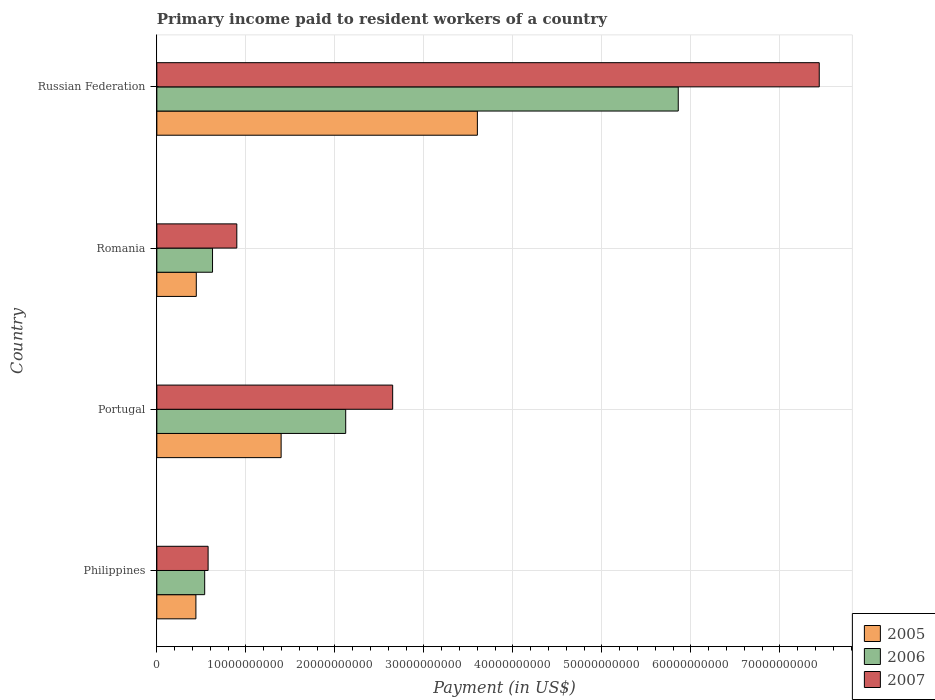Are the number of bars per tick equal to the number of legend labels?
Ensure brevity in your answer.  Yes. Are the number of bars on each tick of the Y-axis equal?
Offer a terse response. Yes. How many bars are there on the 1st tick from the top?
Your answer should be compact. 3. How many bars are there on the 2nd tick from the bottom?
Give a very brief answer. 3. What is the label of the 1st group of bars from the top?
Keep it short and to the point. Russian Federation. What is the amount paid to workers in 2007 in Russian Federation?
Offer a very short reply. 7.44e+1. Across all countries, what is the maximum amount paid to workers in 2006?
Ensure brevity in your answer.  5.86e+1. Across all countries, what is the minimum amount paid to workers in 2005?
Your answer should be very brief. 4.39e+09. In which country was the amount paid to workers in 2007 maximum?
Give a very brief answer. Russian Federation. What is the total amount paid to workers in 2005 in the graph?
Keep it short and to the point. 5.88e+1. What is the difference between the amount paid to workers in 2006 in Portugal and that in Romania?
Provide a succinct answer. 1.50e+1. What is the difference between the amount paid to workers in 2005 in Philippines and the amount paid to workers in 2006 in Portugal?
Your answer should be compact. -1.68e+1. What is the average amount paid to workers in 2006 per country?
Offer a very short reply. 2.29e+1. What is the difference between the amount paid to workers in 2007 and amount paid to workers in 2005 in Philippines?
Your answer should be compact. 1.37e+09. What is the ratio of the amount paid to workers in 2005 in Romania to that in Russian Federation?
Your response must be concise. 0.12. Is the amount paid to workers in 2006 in Philippines less than that in Romania?
Your response must be concise. Yes. Is the difference between the amount paid to workers in 2007 in Portugal and Romania greater than the difference between the amount paid to workers in 2005 in Portugal and Romania?
Provide a short and direct response. Yes. What is the difference between the highest and the second highest amount paid to workers in 2006?
Your answer should be compact. 3.74e+1. What is the difference between the highest and the lowest amount paid to workers in 2005?
Ensure brevity in your answer.  3.16e+1. In how many countries, is the amount paid to workers in 2005 greater than the average amount paid to workers in 2005 taken over all countries?
Keep it short and to the point. 1. Is the sum of the amount paid to workers in 2007 in Portugal and Russian Federation greater than the maximum amount paid to workers in 2006 across all countries?
Offer a terse response. Yes. What does the 3rd bar from the bottom in Philippines represents?
Provide a short and direct response. 2007. How many bars are there?
Your response must be concise. 12. How many countries are there in the graph?
Keep it short and to the point. 4. What is the difference between two consecutive major ticks on the X-axis?
Your response must be concise. 1.00e+1. Does the graph contain any zero values?
Provide a succinct answer. No. Where does the legend appear in the graph?
Provide a short and direct response. Bottom right. How many legend labels are there?
Give a very brief answer. 3. How are the legend labels stacked?
Your answer should be very brief. Vertical. What is the title of the graph?
Your response must be concise. Primary income paid to resident workers of a country. Does "1985" appear as one of the legend labels in the graph?
Keep it short and to the point. No. What is the label or title of the X-axis?
Your response must be concise. Payment (in US$). What is the label or title of the Y-axis?
Your answer should be very brief. Country. What is the Payment (in US$) of 2005 in Philippines?
Offer a terse response. 4.39e+09. What is the Payment (in US$) in 2006 in Philippines?
Make the answer very short. 5.37e+09. What is the Payment (in US$) of 2007 in Philippines?
Offer a very short reply. 5.76e+09. What is the Payment (in US$) of 2005 in Portugal?
Offer a very short reply. 1.40e+1. What is the Payment (in US$) of 2006 in Portugal?
Ensure brevity in your answer.  2.12e+1. What is the Payment (in US$) of 2007 in Portugal?
Give a very brief answer. 2.65e+1. What is the Payment (in US$) in 2005 in Romania?
Your answer should be very brief. 4.43e+09. What is the Payment (in US$) of 2006 in Romania?
Offer a terse response. 6.26e+09. What is the Payment (in US$) in 2007 in Romania?
Offer a very short reply. 8.98e+09. What is the Payment (in US$) of 2005 in Russian Federation?
Give a very brief answer. 3.60e+1. What is the Payment (in US$) in 2006 in Russian Federation?
Give a very brief answer. 5.86e+1. What is the Payment (in US$) of 2007 in Russian Federation?
Ensure brevity in your answer.  7.44e+1. Across all countries, what is the maximum Payment (in US$) in 2005?
Make the answer very short. 3.60e+1. Across all countries, what is the maximum Payment (in US$) in 2006?
Provide a short and direct response. 5.86e+1. Across all countries, what is the maximum Payment (in US$) of 2007?
Keep it short and to the point. 7.44e+1. Across all countries, what is the minimum Payment (in US$) of 2005?
Keep it short and to the point. 4.39e+09. Across all countries, what is the minimum Payment (in US$) of 2006?
Give a very brief answer. 5.37e+09. Across all countries, what is the minimum Payment (in US$) of 2007?
Offer a very short reply. 5.76e+09. What is the total Payment (in US$) of 2005 in the graph?
Provide a succinct answer. 5.88e+1. What is the total Payment (in US$) of 2006 in the graph?
Ensure brevity in your answer.  9.14e+1. What is the total Payment (in US$) in 2007 in the graph?
Offer a very short reply. 1.16e+11. What is the difference between the Payment (in US$) in 2005 in Philippines and that in Portugal?
Your answer should be compact. -9.57e+09. What is the difference between the Payment (in US$) in 2006 in Philippines and that in Portugal?
Make the answer very short. -1.58e+1. What is the difference between the Payment (in US$) of 2007 in Philippines and that in Portugal?
Your answer should be very brief. -2.07e+1. What is the difference between the Payment (in US$) of 2005 in Philippines and that in Romania?
Give a very brief answer. -4.53e+07. What is the difference between the Payment (in US$) of 2006 in Philippines and that in Romania?
Your answer should be very brief. -8.81e+08. What is the difference between the Payment (in US$) of 2007 in Philippines and that in Romania?
Your answer should be compact. -3.23e+09. What is the difference between the Payment (in US$) of 2005 in Philippines and that in Russian Federation?
Your response must be concise. -3.16e+1. What is the difference between the Payment (in US$) of 2006 in Philippines and that in Russian Federation?
Keep it short and to the point. -5.32e+1. What is the difference between the Payment (in US$) of 2007 in Philippines and that in Russian Federation?
Give a very brief answer. -6.87e+1. What is the difference between the Payment (in US$) of 2005 in Portugal and that in Romania?
Keep it short and to the point. 9.53e+09. What is the difference between the Payment (in US$) of 2006 in Portugal and that in Romania?
Offer a terse response. 1.50e+1. What is the difference between the Payment (in US$) of 2007 in Portugal and that in Romania?
Make the answer very short. 1.75e+1. What is the difference between the Payment (in US$) of 2005 in Portugal and that in Russian Federation?
Give a very brief answer. -2.20e+1. What is the difference between the Payment (in US$) in 2006 in Portugal and that in Russian Federation?
Give a very brief answer. -3.74e+1. What is the difference between the Payment (in US$) in 2007 in Portugal and that in Russian Federation?
Offer a terse response. -4.79e+1. What is the difference between the Payment (in US$) of 2005 in Romania and that in Russian Federation?
Offer a terse response. -3.16e+1. What is the difference between the Payment (in US$) of 2006 in Romania and that in Russian Federation?
Your answer should be very brief. -5.23e+1. What is the difference between the Payment (in US$) of 2007 in Romania and that in Russian Federation?
Keep it short and to the point. -6.54e+1. What is the difference between the Payment (in US$) in 2005 in Philippines and the Payment (in US$) in 2006 in Portugal?
Provide a short and direct response. -1.68e+1. What is the difference between the Payment (in US$) of 2005 in Philippines and the Payment (in US$) of 2007 in Portugal?
Your answer should be very brief. -2.21e+1. What is the difference between the Payment (in US$) in 2006 in Philippines and the Payment (in US$) in 2007 in Portugal?
Ensure brevity in your answer.  -2.11e+1. What is the difference between the Payment (in US$) of 2005 in Philippines and the Payment (in US$) of 2006 in Romania?
Your answer should be compact. -1.87e+09. What is the difference between the Payment (in US$) in 2005 in Philippines and the Payment (in US$) in 2007 in Romania?
Give a very brief answer. -4.60e+09. What is the difference between the Payment (in US$) in 2006 in Philippines and the Payment (in US$) in 2007 in Romania?
Keep it short and to the point. -3.61e+09. What is the difference between the Payment (in US$) of 2005 in Philippines and the Payment (in US$) of 2006 in Russian Federation?
Provide a succinct answer. -5.42e+1. What is the difference between the Payment (in US$) of 2005 in Philippines and the Payment (in US$) of 2007 in Russian Federation?
Keep it short and to the point. -7.00e+1. What is the difference between the Payment (in US$) in 2006 in Philippines and the Payment (in US$) in 2007 in Russian Federation?
Give a very brief answer. -6.90e+1. What is the difference between the Payment (in US$) of 2005 in Portugal and the Payment (in US$) of 2006 in Romania?
Give a very brief answer. 7.71e+09. What is the difference between the Payment (in US$) of 2005 in Portugal and the Payment (in US$) of 2007 in Romania?
Offer a terse response. 4.98e+09. What is the difference between the Payment (in US$) in 2006 in Portugal and the Payment (in US$) in 2007 in Romania?
Ensure brevity in your answer.  1.22e+1. What is the difference between the Payment (in US$) in 2005 in Portugal and the Payment (in US$) in 2006 in Russian Federation?
Ensure brevity in your answer.  -4.46e+1. What is the difference between the Payment (in US$) in 2005 in Portugal and the Payment (in US$) in 2007 in Russian Federation?
Provide a short and direct response. -6.05e+1. What is the difference between the Payment (in US$) in 2006 in Portugal and the Payment (in US$) in 2007 in Russian Federation?
Your answer should be very brief. -5.32e+1. What is the difference between the Payment (in US$) in 2005 in Romania and the Payment (in US$) in 2006 in Russian Federation?
Your answer should be compact. -5.41e+1. What is the difference between the Payment (in US$) of 2005 in Romania and the Payment (in US$) of 2007 in Russian Federation?
Give a very brief answer. -7.00e+1. What is the difference between the Payment (in US$) in 2006 in Romania and the Payment (in US$) in 2007 in Russian Federation?
Your answer should be compact. -6.82e+1. What is the average Payment (in US$) of 2005 per country?
Make the answer very short. 1.47e+1. What is the average Payment (in US$) in 2006 per country?
Your response must be concise. 2.29e+1. What is the average Payment (in US$) in 2007 per country?
Give a very brief answer. 2.89e+1. What is the difference between the Payment (in US$) in 2005 and Payment (in US$) in 2006 in Philippines?
Make the answer very short. -9.87e+08. What is the difference between the Payment (in US$) in 2005 and Payment (in US$) in 2007 in Philippines?
Give a very brief answer. -1.37e+09. What is the difference between the Payment (in US$) in 2006 and Payment (in US$) in 2007 in Philippines?
Offer a terse response. -3.84e+08. What is the difference between the Payment (in US$) in 2005 and Payment (in US$) in 2006 in Portugal?
Provide a succinct answer. -7.25e+09. What is the difference between the Payment (in US$) in 2005 and Payment (in US$) in 2007 in Portugal?
Offer a terse response. -1.25e+1. What is the difference between the Payment (in US$) of 2006 and Payment (in US$) of 2007 in Portugal?
Offer a terse response. -5.28e+09. What is the difference between the Payment (in US$) in 2005 and Payment (in US$) in 2006 in Romania?
Keep it short and to the point. -1.82e+09. What is the difference between the Payment (in US$) in 2005 and Payment (in US$) in 2007 in Romania?
Make the answer very short. -4.55e+09. What is the difference between the Payment (in US$) in 2006 and Payment (in US$) in 2007 in Romania?
Ensure brevity in your answer.  -2.73e+09. What is the difference between the Payment (in US$) of 2005 and Payment (in US$) of 2006 in Russian Federation?
Your answer should be compact. -2.26e+1. What is the difference between the Payment (in US$) in 2005 and Payment (in US$) in 2007 in Russian Federation?
Keep it short and to the point. -3.84e+1. What is the difference between the Payment (in US$) of 2006 and Payment (in US$) of 2007 in Russian Federation?
Offer a very short reply. -1.58e+1. What is the ratio of the Payment (in US$) in 2005 in Philippines to that in Portugal?
Keep it short and to the point. 0.31. What is the ratio of the Payment (in US$) in 2006 in Philippines to that in Portugal?
Give a very brief answer. 0.25. What is the ratio of the Payment (in US$) of 2007 in Philippines to that in Portugal?
Provide a short and direct response. 0.22. What is the ratio of the Payment (in US$) of 2005 in Philippines to that in Romania?
Offer a very short reply. 0.99. What is the ratio of the Payment (in US$) in 2006 in Philippines to that in Romania?
Your answer should be compact. 0.86. What is the ratio of the Payment (in US$) of 2007 in Philippines to that in Romania?
Your answer should be very brief. 0.64. What is the ratio of the Payment (in US$) of 2005 in Philippines to that in Russian Federation?
Your answer should be very brief. 0.12. What is the ratio of the Payment (in US$) in 2006 in Philippines to that in Russian Federation?
Ensure brevity in your answer.  0.09. What is the ratio of the Payment (in US$) of 2007 in Philippines to that in Russian Federation?
Offer a very short reply. 0.08. What is the ratio of the Payment (in US$) in 2005 in Portugal to that in Romania?
Ensure brevity in your answer.  3.15. What is the ratio of the Payment (in US$) of 2006 in Portugal to that in Romania?
Make the answer very short. 3.39. What is the ratio of the Payment (in US$) in 2007 in Portugal to that in Romania?
Your answer should be compact. 2.95. What is the ratio of the Payment (in US$) of 2005 in Portugal to that in Russian Federation?
Your response must be concise. 0.39. What is the ratio of the Payment (in US$) in 2006 in Portugal to that in Russian Federation?
Provide a short and direct response. 0.36. What is the ratio of the Payment (in US$) in 2007 in Portugal to that in Russian Federation?
Offer a terse response. 0.36. What is the ratio of the Payment (in US$) in 2005 in Romania to that in Russian Federation?
Provide a succinct answer. 0.12. What is the ratio of the Payment (in US$) in 2006 in Romania to that in Russian Federation?
Ensure brevity in your answer.  0.11. What is the ratio of the Payment (in US$) in 2007 in Romania to that in Russian Federation?
Ensure brevity in your answer.  0.12. What is the difference between the highest and the second highest Payment (in US$) of 2005?
Provide a short and direct response. 2.20e+1. What is the difference between the highest and the second highest Payment (in US$) in 2006?
Make the answer very short. 3.74e+1. What is the difference between the highest and the second highest Payment (in US$) in 2007?
Your answer should be compact. 4.79e+1. What is the difference between the highest and the lowest Payment (in US$) in 2005?
Your response must be concise. 3.16e+1. What is the difference between the highest and the lowest Payment (in US$) in 2006?
Your answer should be compact. 5.32e+1. What is the difference between the highest and the lowest Payment (in US$) of 2007?
Offer a terse response. 6.87e+1. 